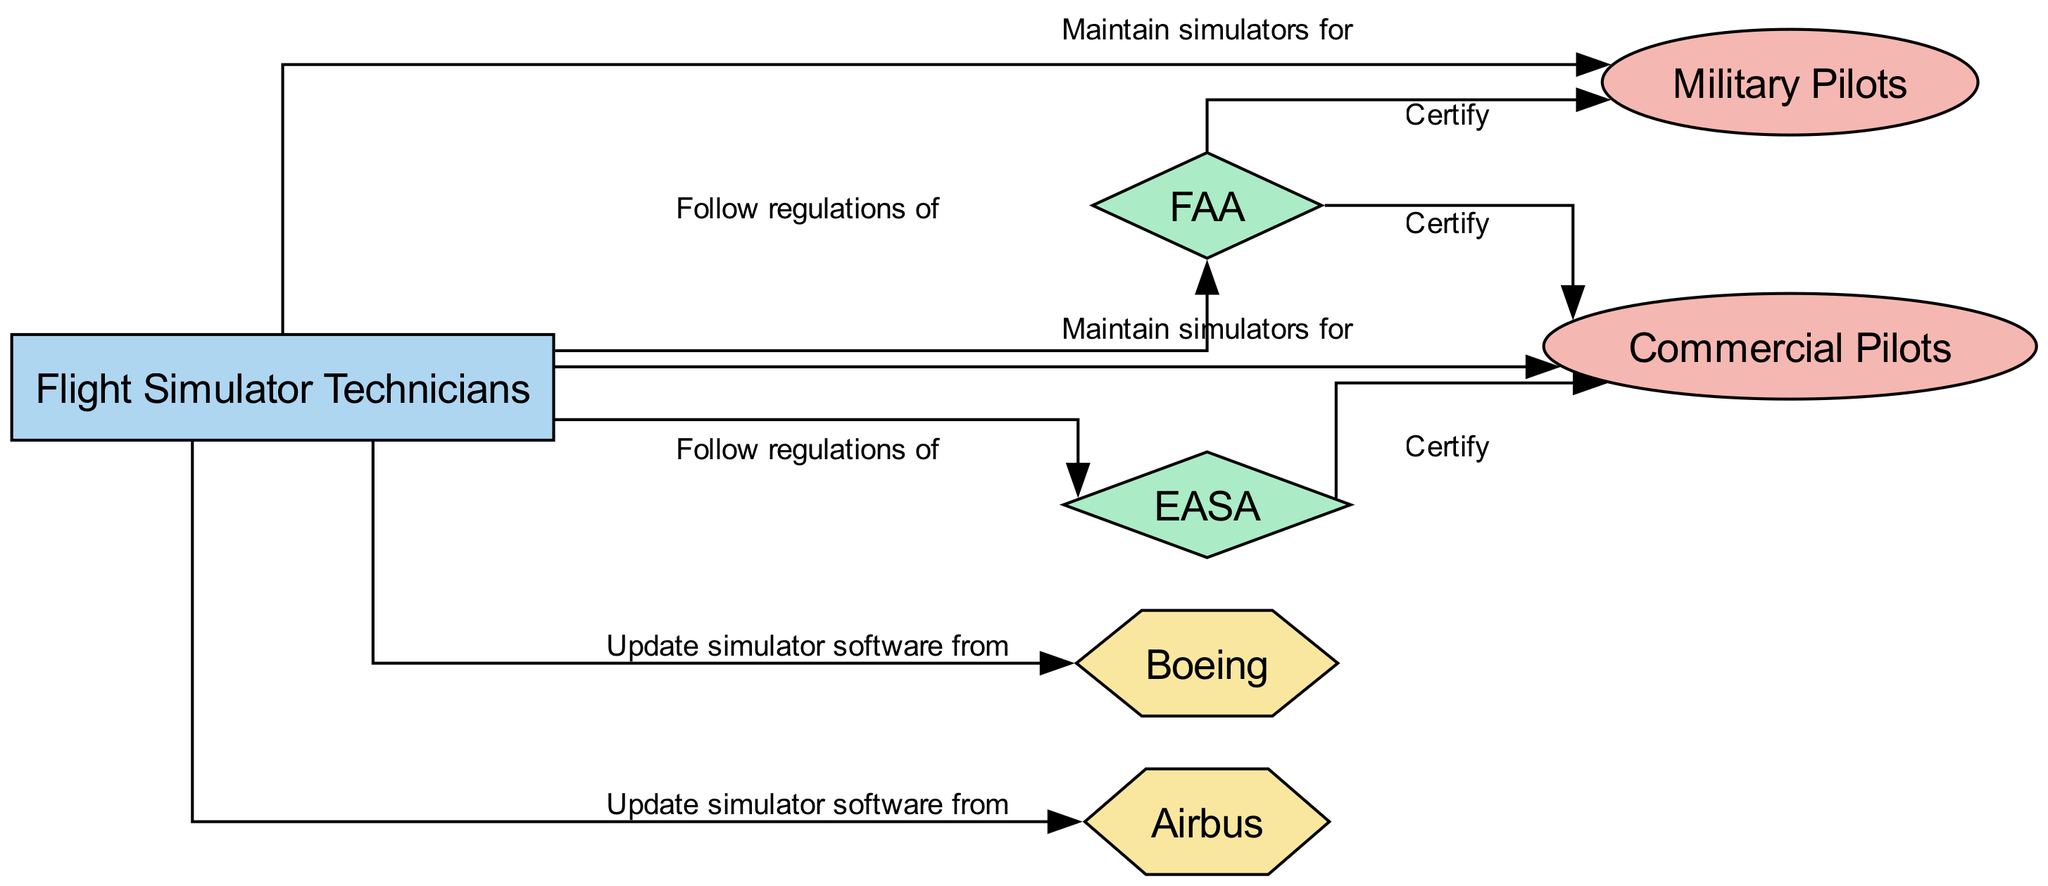What is the label of the node representing Flight Simulator Technicians? The diagram includes multiple nodes, and the one that corresponds with 'Flight Simulator Technicians' is noted by its label. Such labels provide a direct description of each node's identity.
Answer: Flight Simulator Technicians How many regulatory bodies are represented in the diagram? By examining the nodes in the diagram, we can identify which ones belong to the category of "Regulatory Body." There are two nodes listed under this category, namely FAA and EASA.
Answer: 2 What relationship do Flight Simulator Technicians have with Commercial Pilots? The edge connecting the node for Flight Simulator Technicians to the node for Commercial Pilots indicates the nature of their relationship, which is described by the label on the edge.
Answer: Maintain simulators for Who certifies Military Pilots? The diagram indicates that Military Pilots are connected to a regulatory body with a certification relationship. Studying the connections, we find that both FAA and EASA have edges showing certification roles toward the Military Pilots node.
Answer: FAA, EASA Which node updates simulator software from Boeing? The edge connecting Flight Simulator Technicians to the Boeing node indicates a specific action related to software updates. By identifying the nodes and how they relate, we can pinpoint the action using the edge label.
Answer: Flight Simulator Technicians How many edges are shown in the diagram? By counting the lines that connect nodes, which represent relationships or actions, we can determine the total number of edges present in the diagram. There are eight edges listed within the connections.
Answer: 8 What type of node is EASA? The classification of the EASA node falls under the category of regulatory bodies. Observing the node's type will clarify its role in the network depicted in the diagram.
Answer: Regulatory Body Which nodes do Flight Simulator Technicians follow regulations of? Based on the connections originating from the Flight Simulator Technicians node, we can identify the relationships that detail the regulatory frameworks they adhere to. There are two regulatory bodies in this relationship: FAA and EASA.
Answer: FAA, EASA How many types of nodes are present in the diagram? By analyzing the nodes and categorizing them based on the given classifications, we can identify the diversity of roles present in the diagram. There are four distinct categories represented: Technicians, Pilots, Regulatory Body, and Manufacturer.
Answer: 4 